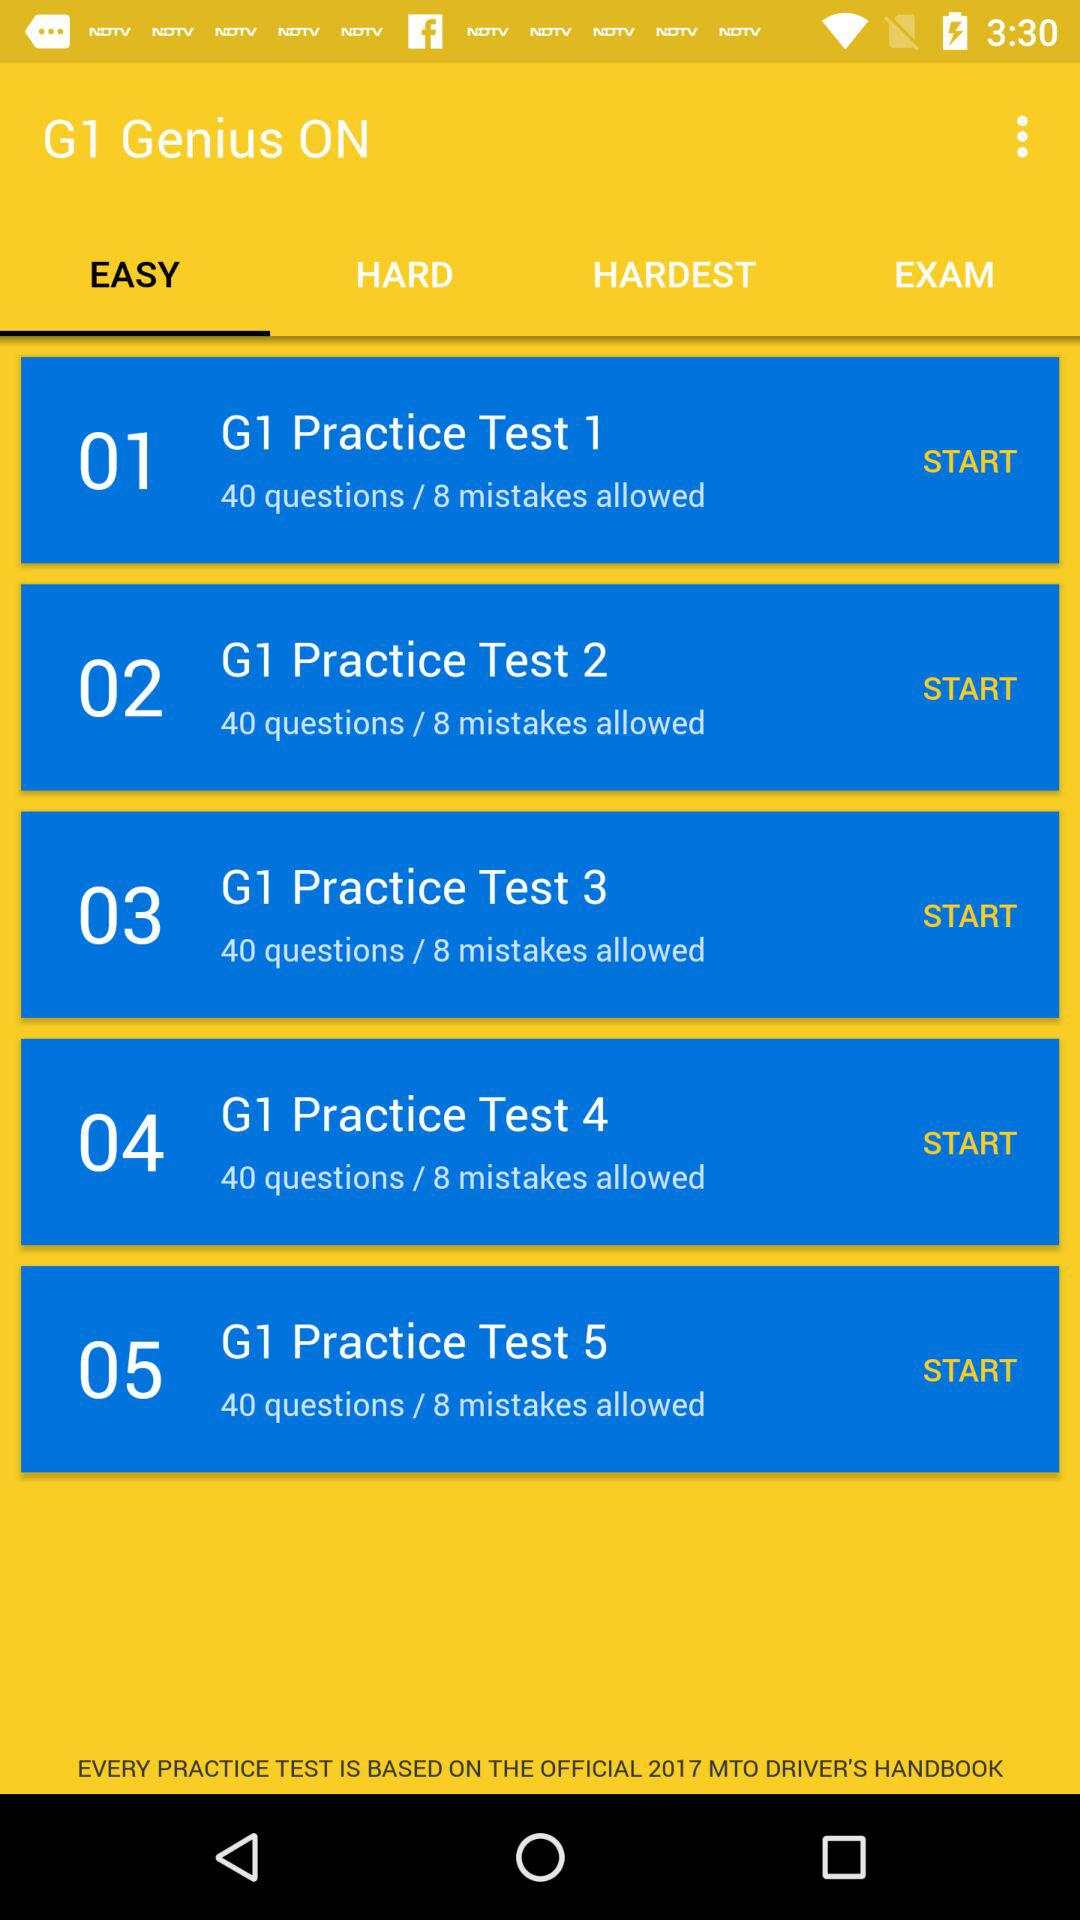How many questions does "G1 Practice Test 2" have? "G1 Practice Test 2" has 40 questions. 